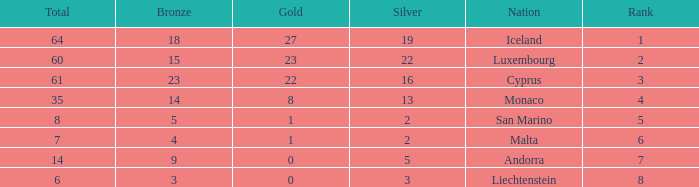I'm looking to parse the entire table for insights. Could you assist me with that? {'header': ['Total', 'Bronze', 'Gold', 'Silver', 'Nation', 'Rank'], 'rows': [['64', '18', '27', '19', 'Iceland', '1'], ['60', '15', '23', '22', 'Luxembourg', '2'], ['61', '23', '22', '16', 'Cyprus', '3'], ['35', '14', '8', '13', 'Monaco', '4'], ['8', '5', '1', '2', 'San Marino', '5'], ['7', '4', '1', '2', 'Malta', '6'], ['14', '9', '0', '5', 'Andorra', '7'], ['6', '3', '0', '3', 'Liechtenstein', '8']]} Where does Iceland rank with under 19 silvers? None. 